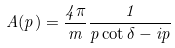Convert formula to latex. <formula><loc_0><loc_0><loc_500><loc_500>A ( p ) = \frac { 4 \pi } { m } \frac { 1 } { p \cot \delta - i p }</formula> 